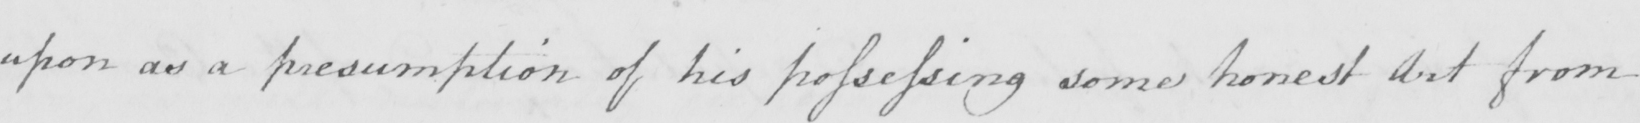What is written in this line of handwriting? upon as a presumption of his possessing some honest Art from 